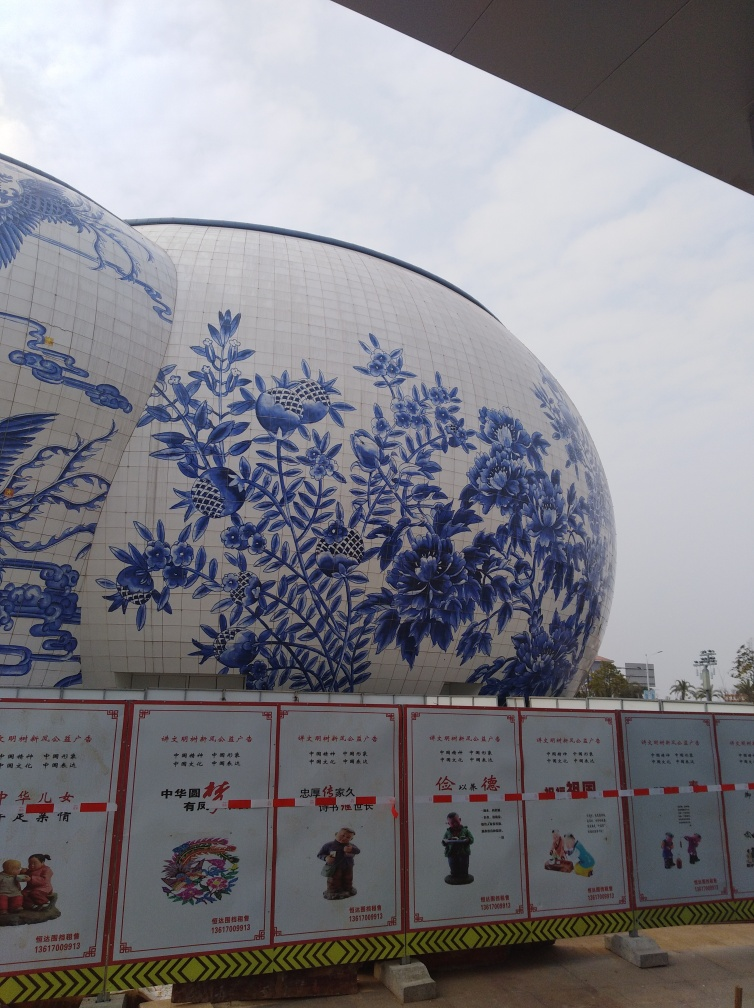What might be the purpose of such a building? While I can't provide specific details without more context, buildings with such distinctive and ornate designs are often cultural landmarks or museums. This one might serve as a gallery or exhibition space dedicated to showcasing art or history, possibly related to the artistry of Chinese porcelain. Is it possible that this building is part of a larger cultural center or complex? Yes, that's plausible. Considering the grandeur and thematic design, it could be part of a cultural park or district aimed at celebrating artistic traditions, educating the public, and attracting tourism. The signage in front also suggests the presence of other attractions or information points, indicating it could be one element within a cultural hub. 